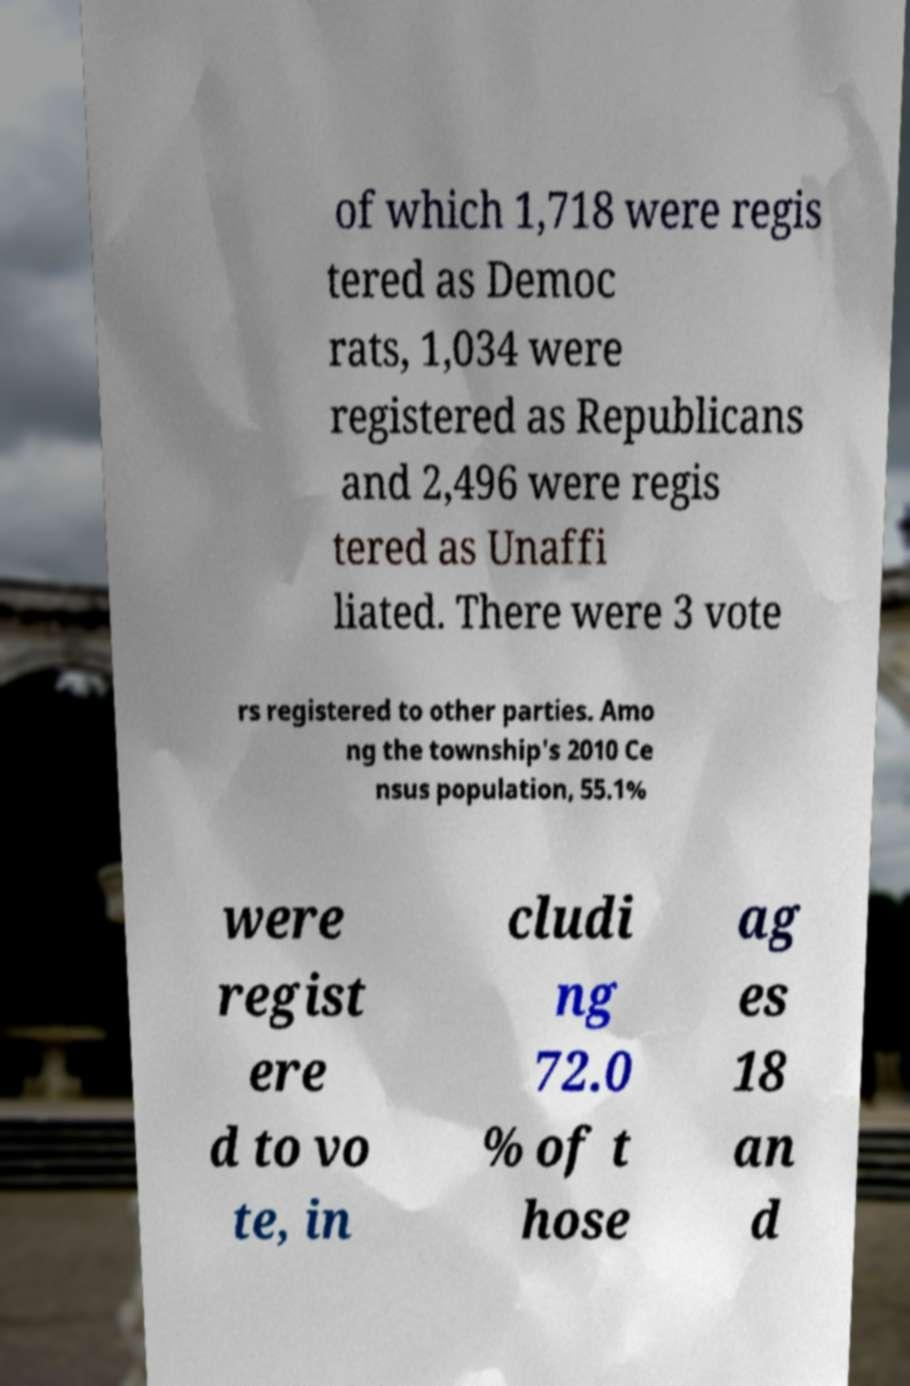Can you read and provide the text displayed in the image?This photo seems to have some interesting text. Can you extract and type it out for me? of which 1,718 were regis tered as Democ rats, 1,034 were registered as Republicans and 2,496 were regis tered as Unaffi liated. There were 3 vote rs registered to other parties. Amo ng the township's 2010 Ce nsus population, 55.1% were regist ere d to vo te, in cludi ng 72.0 % of t hose ag es 18 an d 